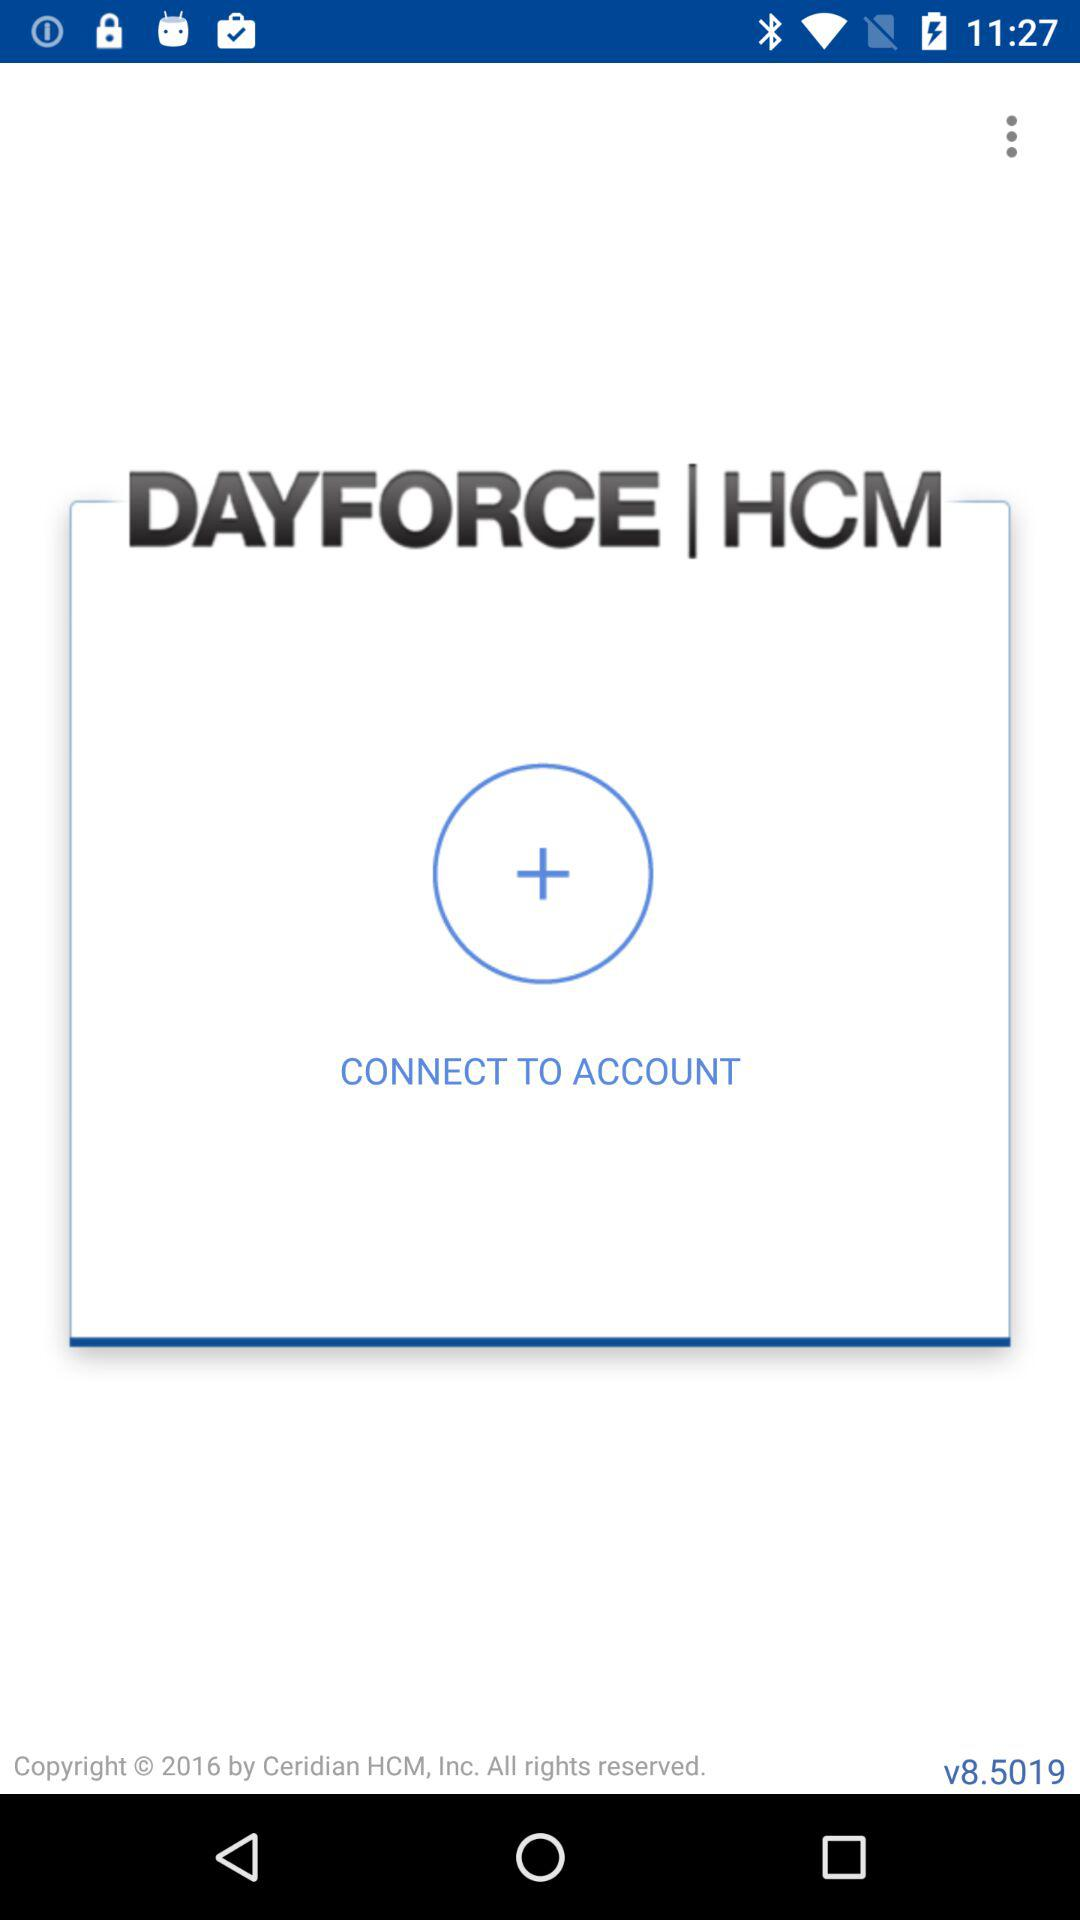Who is connecting to the account?
When the provided information is insufficient, respond with <no answer>. <no answer> 